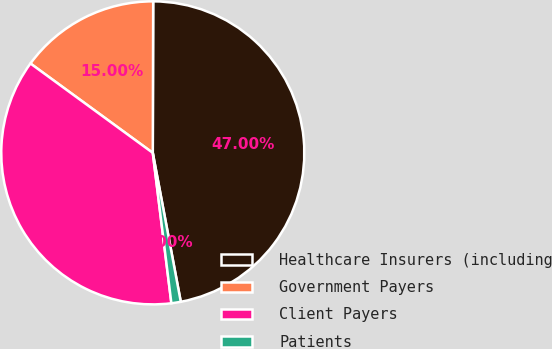<chart> <loc_0><loc_0><loc_500><loc_500><pie_chart><fcel>Healthcare Insurers (including<fcel>Government Payers<fcel>Client Payers<fcel>Patients<nl><fcel>47.0%<fcel>15.0%<fcel>37.0%<fcel>1.0%<nl></chart> 